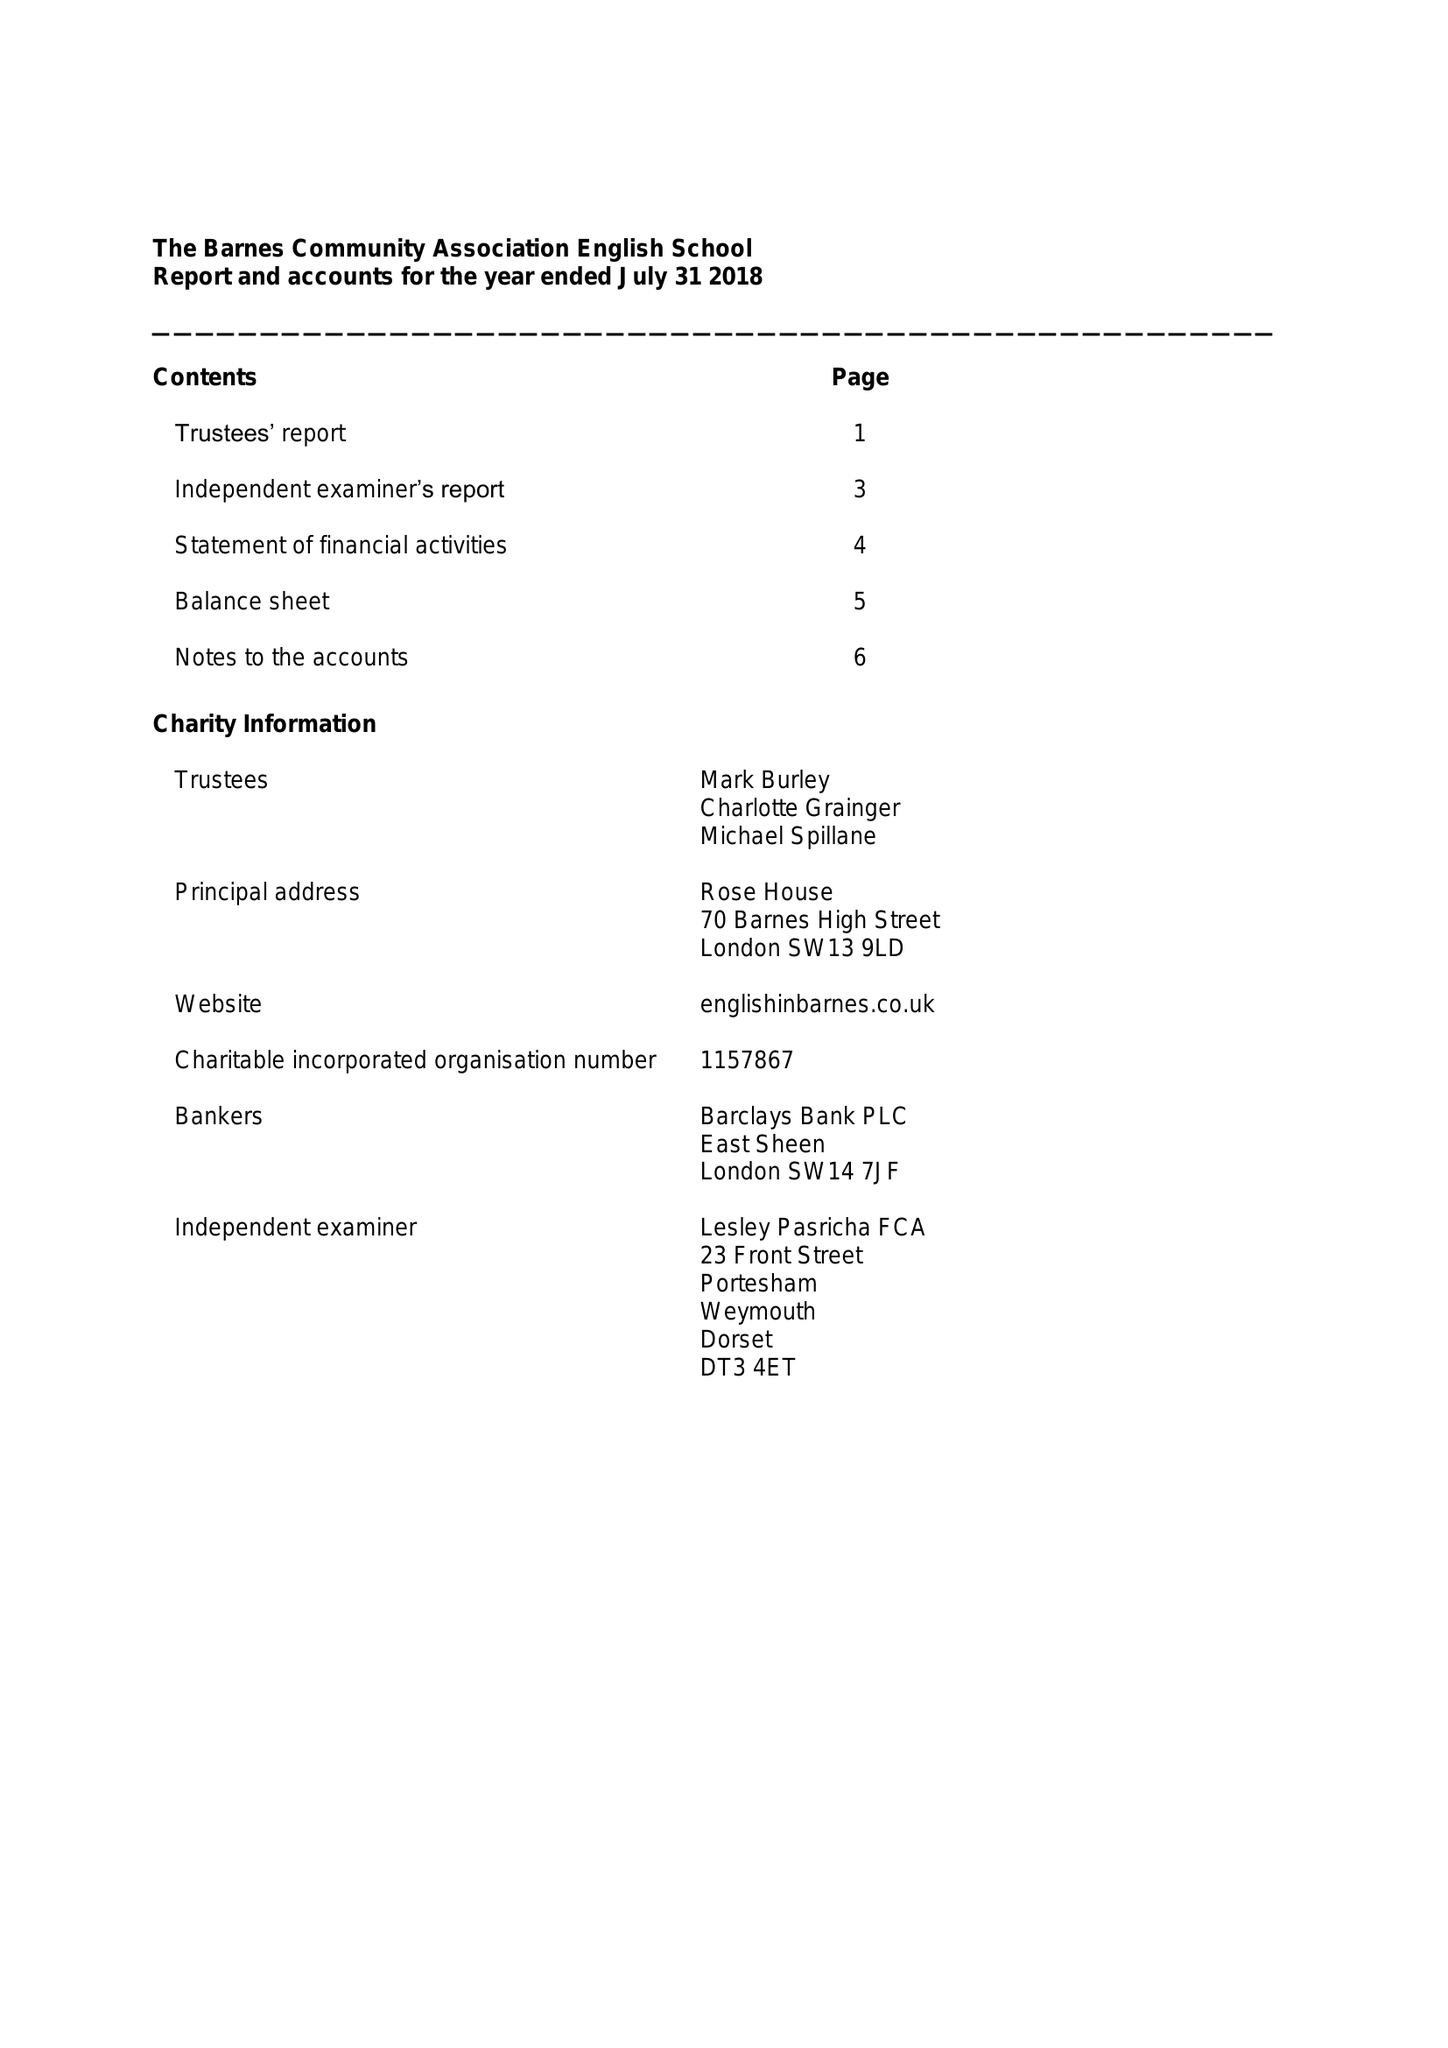What is the value for the charity_number?
Answer the question using a single word or phrase. 1157867 